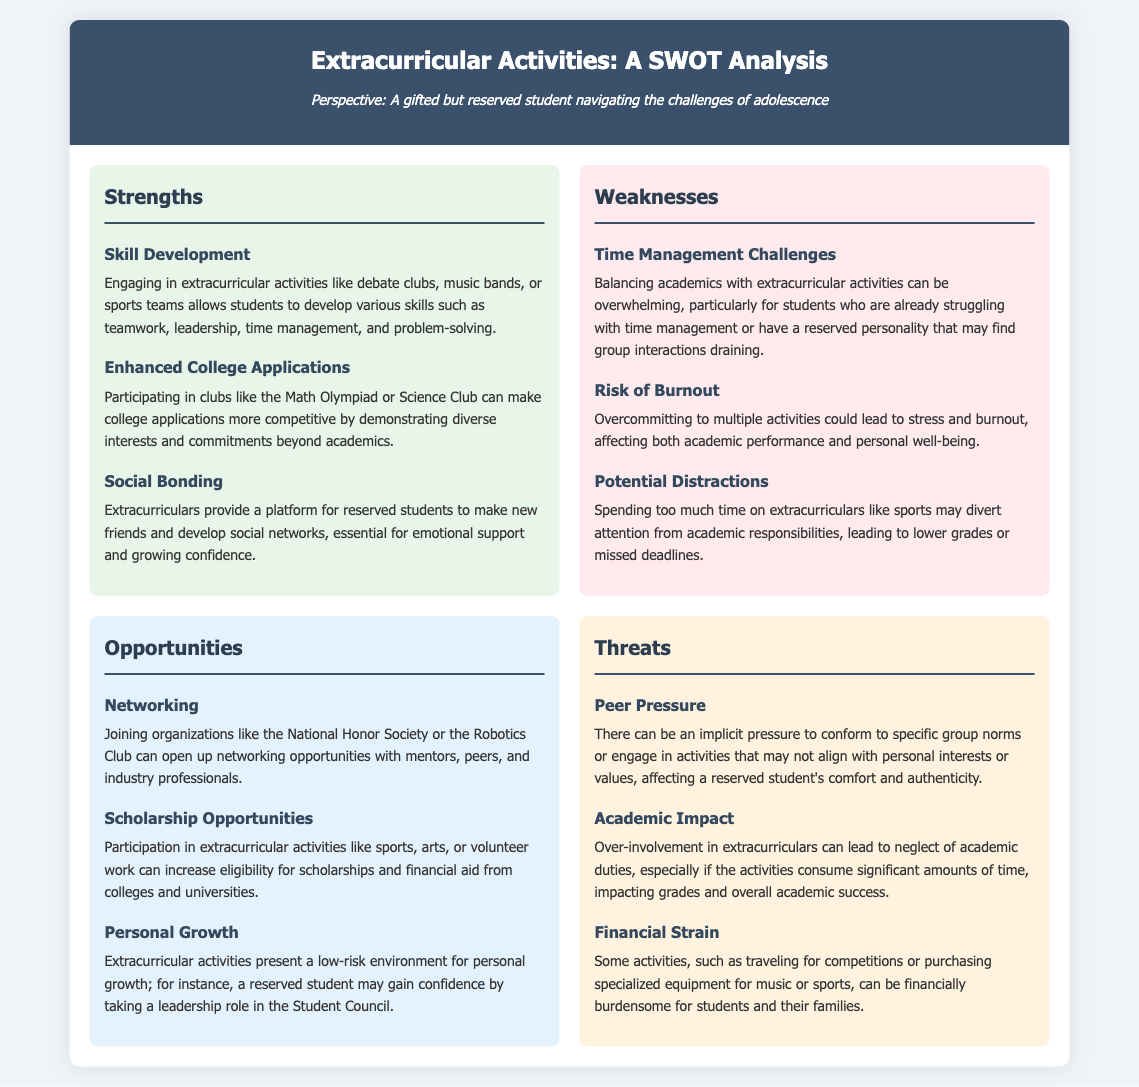What are two examples of skill development in extracurricular activities? The document lists teamwork and leadership as examples of skill development acquired through extracurricular activities.
Answer: teamwork, leadership What can enhance college applications? Participation in clubs like the Math Olympiad or Science Club is mentioned as a way to enhance college applications by demonstrating diverse interests.
Answer: clubs like the Math Olympiad or Science Club What is a time management challenge mentioned? The document states that balancing academics with extracurricular activities can be overwhelming.
Answer: balancing academics with extracurricular activities What opportunity can arise from joining organizations like the National Honor Society? The document highlights that joining such organizations can open networking opportunities with mentors and peers.
Answer: networking opportunities What could lead to financial strain for students? Participation in activities that require travel for competitions or purchasing specialized equipment is noted as a cause of financial strain.
Answer: travel for competitions or purchasing specialized equipment What is a potential risk of overcommitting to multiple activities? The document mentions that doing so could lead to stress and burnout.
Answer: stress and burnout Which extracurricular activity can increase eligibility for scholarships? The document states that participation in sports, arts, or volunteer work can increase eligibility for scholarships.
Answer: sports, arts, or volunteer work What threat is associated with peer pressure in extracurriculars? The document mentions that there can be pressure to conform to specific group norms affecting a student's comfort.
Answer: pressure to conform to specific group norms 